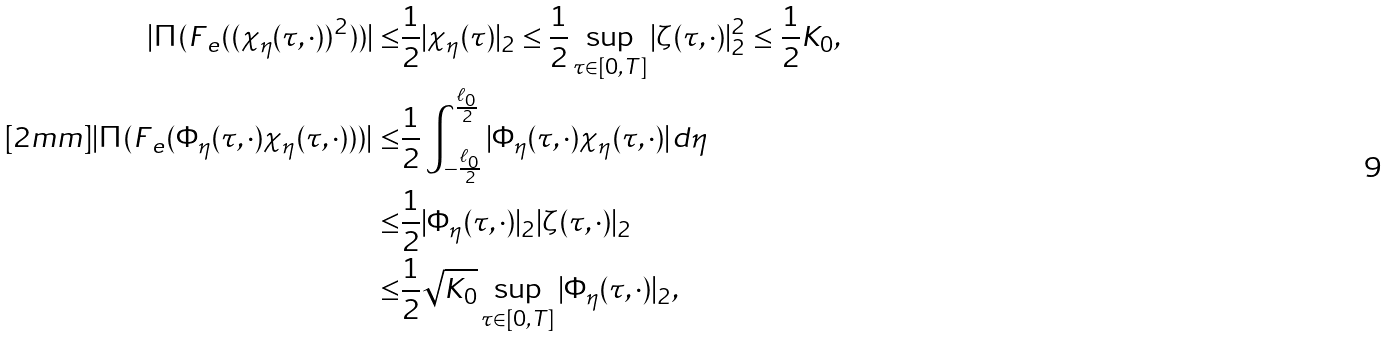Convert formula to latex. <formula><loc_0><loc_0><loc_500><loc_500>| \Pi ( F _ { \ e } ( ( \chi _ { \eta } ( \tau , \cdot ) ) ^ { 2 } ) ) | \leq & \frac { 1 } { 2 } | \chi _ { \eta } ( \tau ) | _ { 2 } \leq \frac { 1 } { 2 } \sup _ { \tau \in [ 0 , T ] } | \zeta ( \tau , \cdot ) | _ { 2 } ^ { 2 } \leq \frac { 1 } { 2 } K _ { 0 } , \\ [ 2 m m ] | \Pi ( F _ { \ e } ( \Phi _ { \eta } ( \tau , \cdot ) \chi _ { \eta } ( \tau , \cdot ) ) ) | \leq & \frac { 1 } { 2 } \int _ { - \frac { \ell _ { 0 } } { 2 } } ^ { \frac { \ell _ { 0 } } { 2 } } | \Phi _ { \eta } ( \tau , \cdot ) \chi _ { \eta } ( \tau , \cdot ) | d \eta \\ \leq & \frac { 1 } { 2 } | \Phi _ { \eta } ( \tau , \cdot ) | _ { 2 } | \zeta ( \tau , \cdot ) | _ { 2 } \\ \leq & \frac { 1 } { 2 } \sqrt { K _ { 0 } } \sup _ { \tau \in [ 0 , T ] } | \Phi _ { \eta } ( \tau , \cdot ) | _ { 2 } ,</formula> 